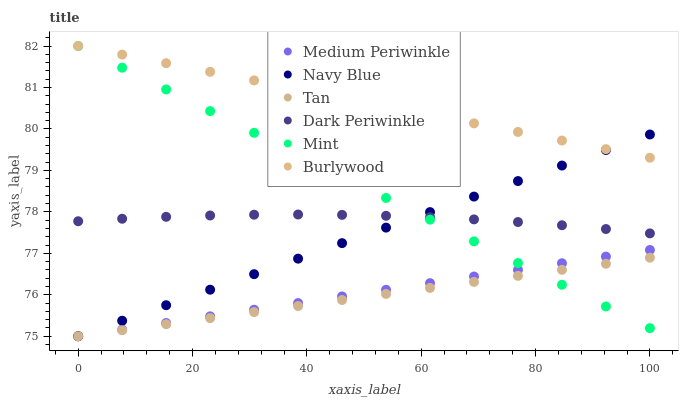Does Tan have the minimum area under the curve?
Answer yes or no. Yes. Does Burlywood have the maximum area under the curve?
Answer yes or no. Yes. Does Navy Blue have the minimum area under the curve?
Answer yes or no. No. Does Navy Blue have the maximum area under the curve?
Answer yes or no. No. Is Navy Blue the smoothest?
Answer yes or no. Yes. Is Dark Periwinkle the roughest?
Answer yes or no. Yes. Is Medium Periwinkle the smoothest?
Answer yes or no. No. Is Medium Periwinkle the roughest?
Answer yes or no. No. Does Navy Blue have the lowest value?
Answer yes or no. Yes. Does Mint have the lowest value?
Answer yes or no. No. Does Mint have the highest value?
Answer yes or no. Yes. Does Navy Blue have the highest value?
Answer yes or no. No. Is Medium Periwinkle less than Dark Periwinkle?
Answer yes or no. Yes. Is Burlywood greater than Medium Periwinkle?
Answer yes or no. Yes. Does Medium Periwinkle intersect Navy Blue?
Answer yes or no. Yes. Is Medium Periwinkle less than Navy Blue?
Answer yes or no. No. Is Medium Periwinkle greater than Navy Blue?
Answer yes or no. No. Does Medium Periwinkle intersect Dark Periwinkle?
Answer yes or no. No. 